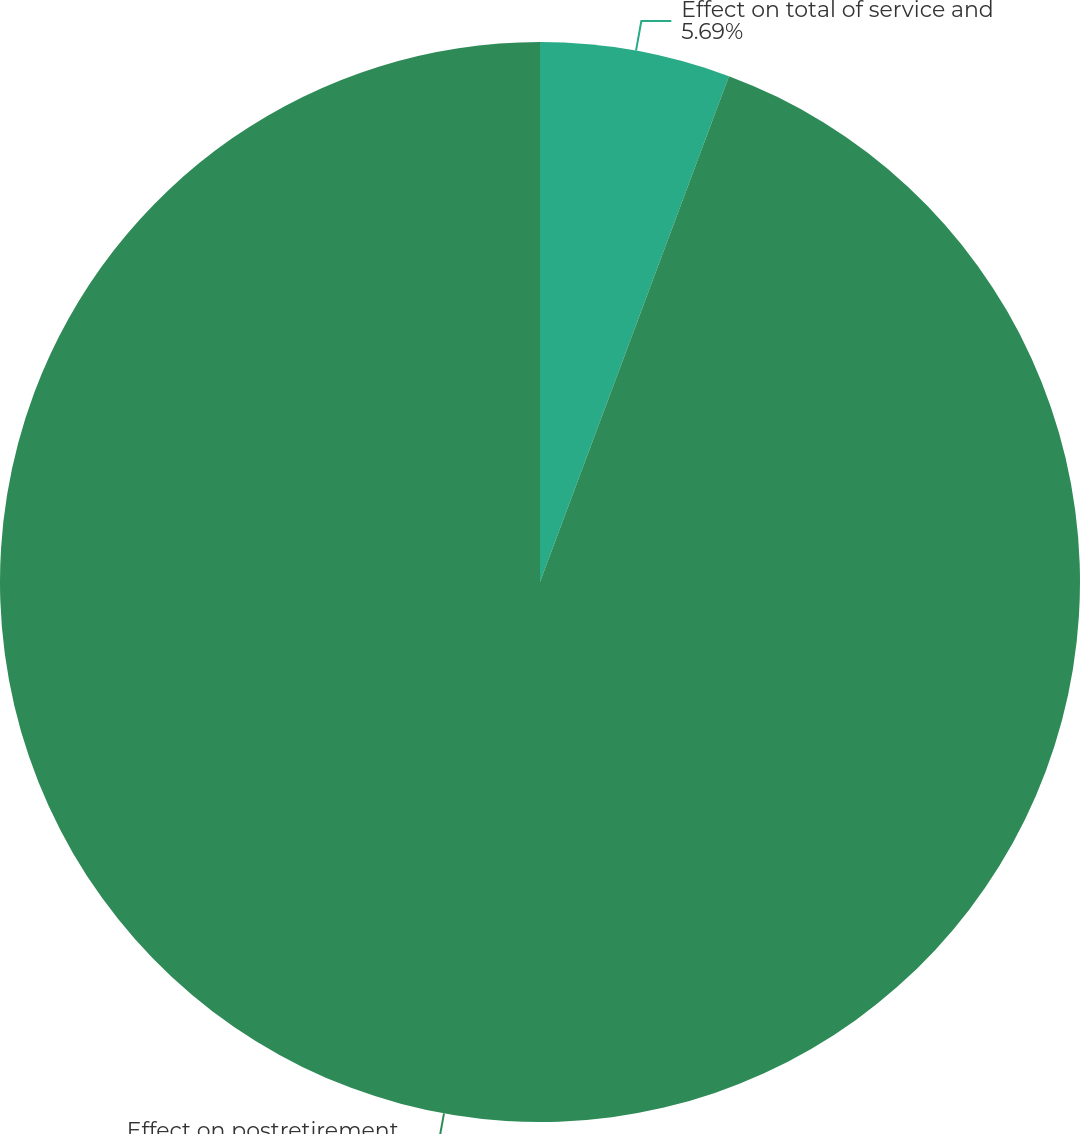<chart> <loc_0><loc_0><loc_500><loc_500><pie_chart><fcel>Effect on total of service and<fcel>Effect on postretirement<nl><fcel>5.69%<fcel>94.31%<nl></chart> 